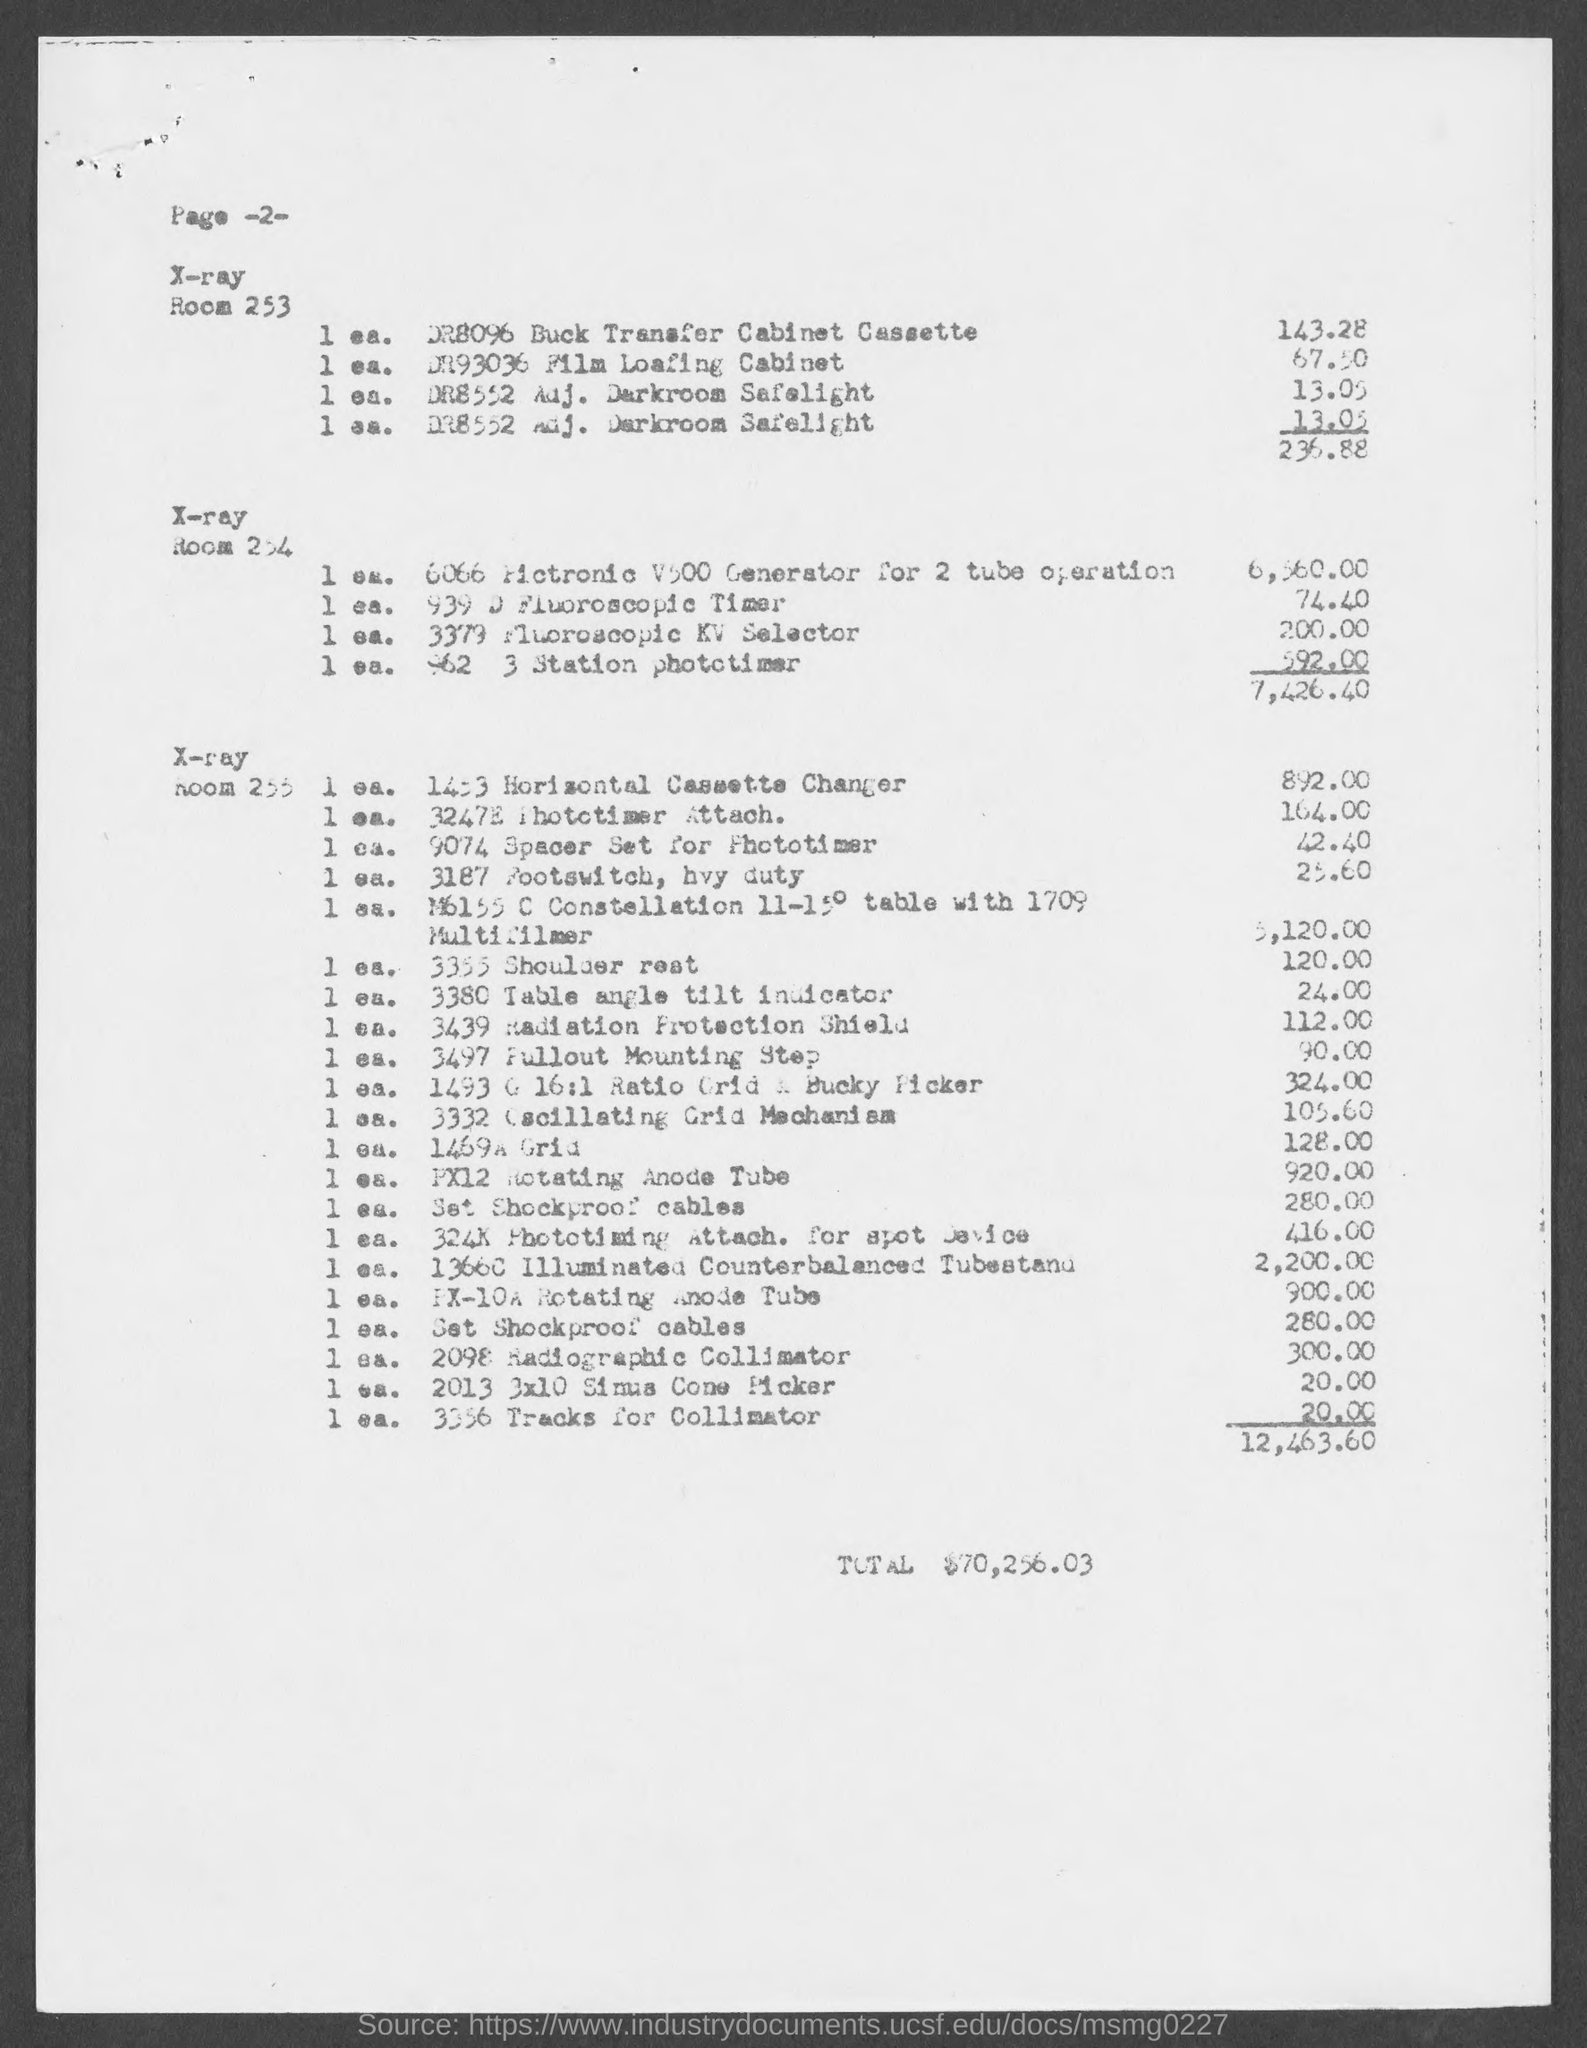What is the total amount given in the document?
Provide a short and direct response. $70,256.03. 